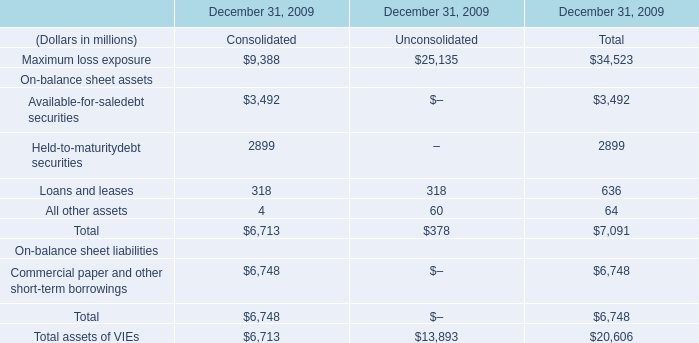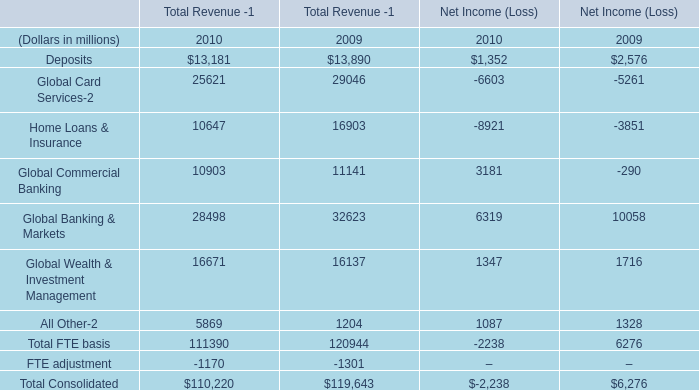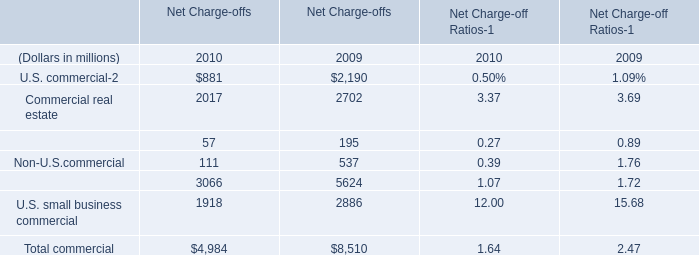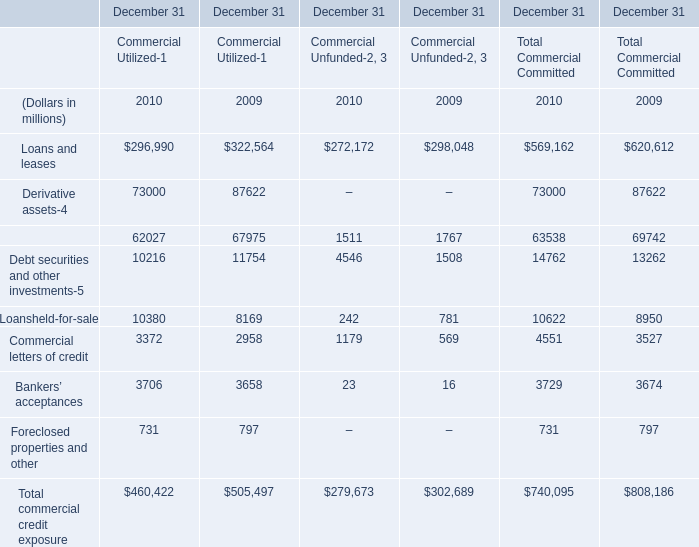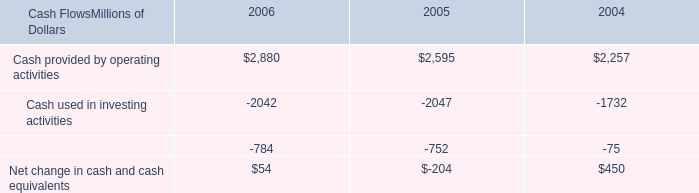What will Commercial lease financing reach in 2011 if it continues to grow at its current rate? (in million) 
Computations: ((1 + ((57 - 195) / 195)) * 57)
Answer: 16.66154. 